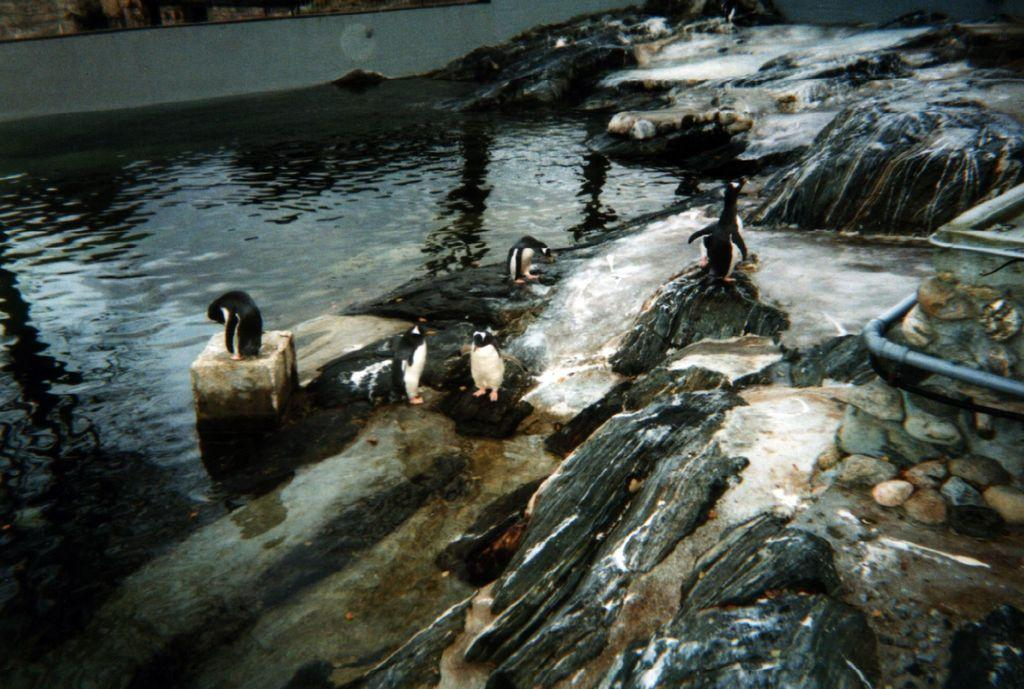What type of natural elements can be seen in the image? There are stones and rocks in the image. What animals are present in the image? There are penguins in the image. What is the surrounding environment like in the image? There is water visible in the image. What type of letters can be seen floating in the water in the image? There are no letters present in the image; it only features stones, rocks, penguins, and water. 